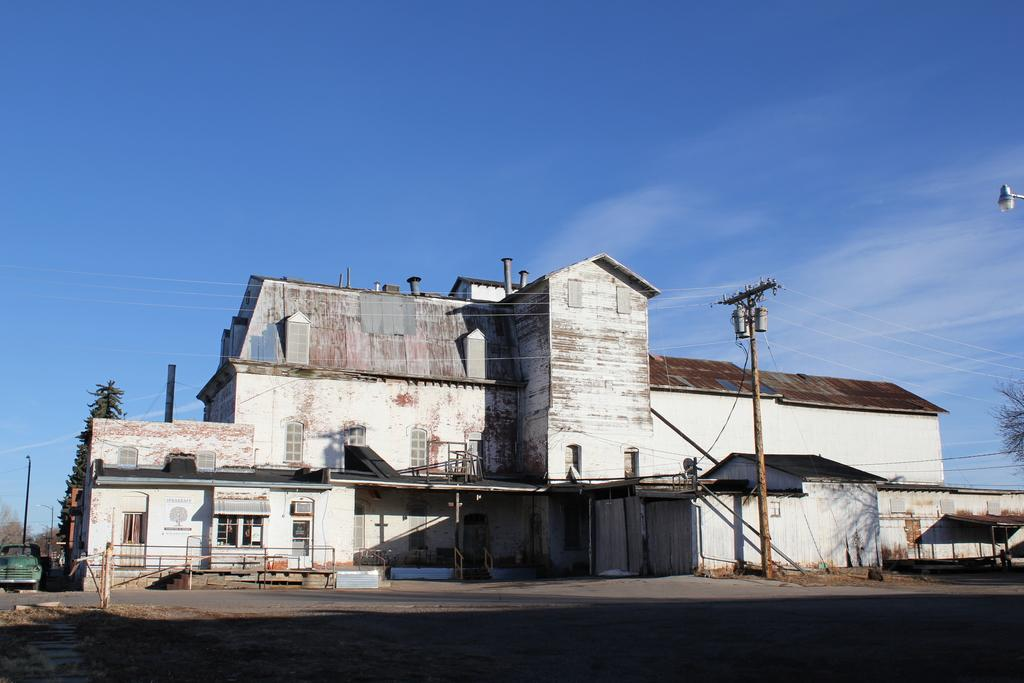What type of structure can be seen in the image? There is a building in the image. What else is present in the image besides the building? There is a vehicle, poles, electric poles and cables, a fence, a street light, and clouds in the sky in the image. How many minutes does it take for the rod to pass through the floor in the image? There is no rod or floor present in the image, so this question cannot be answered. 